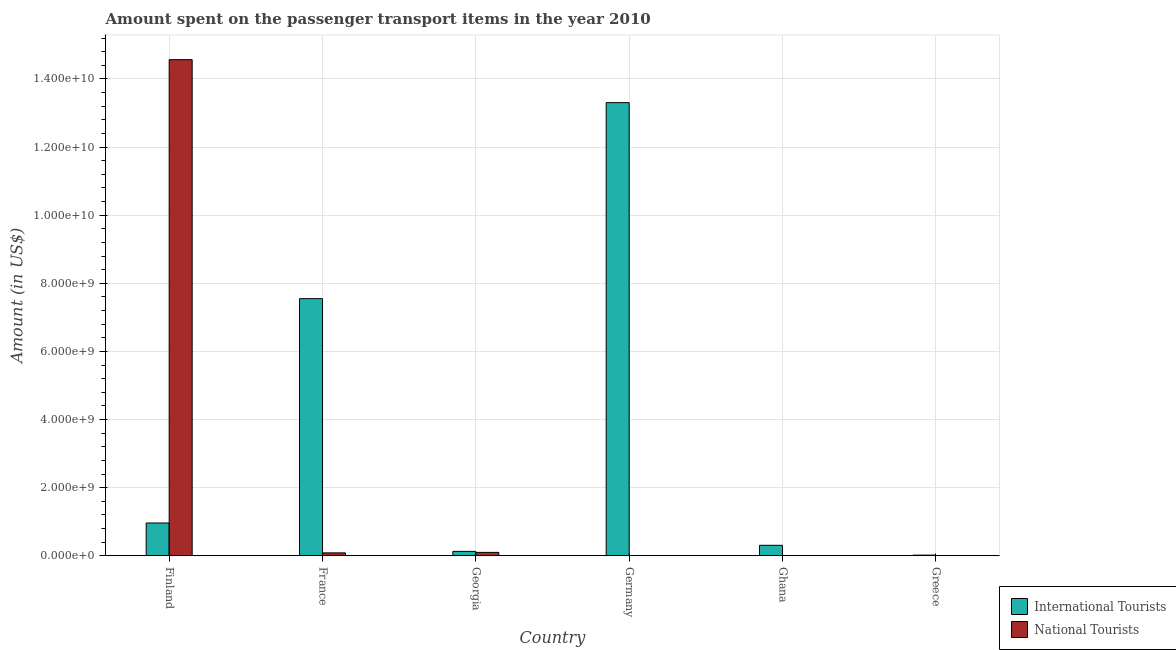Are the number of bars per tick equal to the number of legend labels?
Keep it short and to the point. Yes. Are the number of bars on each tick of the X-axis equal?
Make the answer very short. Yes. How many bars are there on the 2nd tick from the left?
Provide a succinct answer. 2. How many bars are there on the 4th tick from the right?
Provide a succinct answer. 2. What is the amount spent on transport items of national tourists in Greece?
Your answer should be compact. 1.70e+06. Across all countries, what is the maximum amount spent on transport items of national tourists?
Offer a very short reply. 1.46e+1. In which country was the amount spent on transport items of national tourists maximum?
Your answer should be compact. Finland. What is the total amount spent on transport items of international tourists in the graph?
Your response must be concise. 2.23e+1. What is the difference between the amount spent on transport items of national tourists in Georgia and that in Germany?
Provide a short and direct response. 1.00e+08. What is the difference between the amount spent on transport items of national tourists in Ghana and the amount spent on transport items of international tourists in Greece?
Make the answer very short. -1.97e+07. What is the average amount spent on transport items of national tourists per country?
Your answer should be very brief. 2.46e+09. What is the difference between the amount spent on transport items of international tourists and amount spent on transport items of national tourists in Ghana?
Offer a terse response. 3.08e+08. What is the ratio of the amount spent on transport items of national tourists in Germany to that in Ghana?
Offer a terse response. 0.13. Is the amount spent on transport items of international tourists in Germany less than that in Ghana?
Offer a very short reply. No. Is the difference between the amount spent on transport items of national tourists in Georgia and Germany greater than the difference between the amount spent on transport items of international tourists in Georgia and Germany?
Provide a short and direct response. Yes. What is the difference between the highest and the second highest amount spent on transport items of national tourists?
Ensure brevity in your answer.  1.45e+1. What is the difference between the highest and the lowest amount spent on transport items of international tourists?
Offer a terse response. 1.33e+1. Is the sum of the amount spent on transport items of international tourists in Finland and Germany greater than the maximum amount spent on transport items of national tourists across all countries?
Ensure brevity in your answer.  No. What does the 1st bar from the left in Finland represents?
Your answer should be compact. International Tourists. What does the 1st bar from the right in Ghana represents?
Provide a short and direct response. National Tourists. How many bars are there?
Ensure brevity in your answer.  12. How many countries are there in the graph?
Provide a succinct answer. 6. What is the difference between two consecutive major ticks on the Y-axis?
Offer a terse response. 2.00e+09. Are the values on the major ticks of Y-axis written in scientific E-notation?
Your answer should be compact. Yes. Does the graph contain any zero values?
Ensure brevity in your answer.  No. Does the graph contain grids?
Ensure brevity in your answer.  Yes. Where does the legend appear in the graph?
Keep it short and to the point. Bottom right. How many legend labels are there?
Offer a very short reply. 2. How are the legend labels stacked?
Provide a short and direct response. Vertical. What is the title of the graph?
Make the answer very short. Amount spent on the passenger transport items in the year 2010. What is the label or title of the X-axis?
Your answer should be compact. Country. What is the Amount (in US$) in International Tourists in Finland?
Your answer should be compact. 9.63e+08. What is the Amount (in US$) of National Tourists in Finland?
Your answer should be very brief. 1.46e+1. What is the Amount (in US$) in International Tourists in France?
Provide a short and direct response. 7.55e+09. What is the Amount (in US$) in National Tourists in France?
Your answer should be compact. 8.60e+07. What is the Amount (in US$) of International Tourists in Georgia?
Make the answer very short. 1.30e+08. What is the Amount (in US$) of National Tourists in Georgia?
Your answer should be very brief. 1.00e+08. What is the Amount (in US$) in International Tourists in Germany?
Provide a short and direct response. 1.33e+1. What is the Amount (in US$) of International Tourists in Ghana?
Keep it short and to the point. 3.08e+08. What is the Amount (in US$) in National Tourists in Greece?
Your answer should be very brief. 1.70e+06. Across all countries, what is the maximum Amount (in US$) of International Tourists?
Your answer should be very brief. 1.33e+1. Across all countries, what is the maximum Amount (in US$) in National Tourists?
Offer a terse response. 1.46e+1. Across all countries, what is the minimum Amount (in US$) in National Tourists?
Offer a terse response. 4.00e+04. What is the total Amount (in US$) of International Tourists in the graph?
Give a very brief answer. 2.23e+1. What is the total Amount (in US$) of National Tourists in the graph?
Your answer should be compact. 1.48e+1. What is the difference between the Amount (in US$) of International Tourists in Finland and that in France?
Your answer should be compact. -6.59e+09. What is the difference between the Amount (in US$) of National Tourists in Finland and that in France?
Give a very brief answer. 1.45e+1. What is the difference between the Amount (in US$) of International Tourists in Finland and that in Georgia?
Keep it short and to the point. 8.33e+08. What is the difference between the Amount (in US$) of National Tourists in Finland and that in Georgia?
Keep it short and to the point. 1.45e+1. What is the difference between the Amount (in US$) of International Tourists in Finland and that in Germany?
Give a very brief answer. -1.23e+1. What is the difference between the Amount (in US$) of National Tourists in Finland and that in Germany?
Keep it short and to the point. 1.46e+1. What is the difference between the Amount (in US$) of International Tourists in Finland and that in Ghana?
Make the answer very short. 6.55e+08. What is the difference between the Amount (in US$) of National Tourists in Finland and that in Ghana?
Give a very brief answer. 1.46e+1. What is the difference between the Amount (in US$) in International Tourists in Finland and that in Greece?
Provide a short and direct response. 9.43e+08. What is the difference between the Amount (in US$) of National Tourists in Finland and that in Greece?
Your response must be concise. 1.46e+1. What is the difference between the Amount (in US$) of International Tourists in France and that in Georgia?
Your response must be concise. 7.42e+09. What is the difference between the Amount (in US$) in National Tourists in France and that in Georgia?
Give a very brief answer. -1.40e+07. What is the difference between the Amount (in US$) in International Tourists in France and that in Germany?
Offer a terse response. -5.75e+09. What is the difference between the Amount (in US$) in National Tourists in France and that in Germany?
Your answer should be very brief. 8.60e+07. What is the difference between the Amount (in US$) in International Tourists in France and that in Ghana?
Your response must be concise. 7.24e+09. What is the difference between the Amount (in US$) of National Tourists in France and that in Ghana?
Give a very brief answer. 8.57e+07. What is the difference between the Amount (in US$) in International Tourists in France and that in Greece?
Your answer should be compact. 7.53e+09. What is the difference between the Amount (in US$) of National Tourists in France and that in Greece?
Provide a short and direct response. 8.43e+07. What is the difference between the Amount (in US$) in International Tourists in Georgia and that in Germany?
Give a very brief answer. -1.32e+1. What is the difference between the Amount (in US$) in National Tourists in Georgia and that in Germany?
Provide a succinct answer. 1.00e+08. What is the difference between the Amount (in US$) of International Tourists in Georgia and that in Ghana?
Your answer should be very brief. -1.78e+08. What is the difference between the Amount (in US$) of National Tourists in Georgia and that in Ghana?
Give a very brief answer. 9.97e+07. What is the difference between the Amount (in US$) in International Tourists in Georgia and that in Greece?
Provide a succinct answer. 1.10e+08. What is the difference between the Amount (in US$) of National Tourists in Georgia and that in Greece?
Provide a succinct answer. 9.83e+07. What is the difference between the Amount (in US$) of International Tourists in Germany and that in Ghana?
Provide a short and direct response. 1.30e+1. What is the difference between the Amount (in US$) in National Tourists in Germany and that in Ghana?
Provide a short and direct response. -2.60e+05. What is the difference between the Amount (in US$) in International Tourists in Germany and that in Greece?
Your answer should be compact. 1.33e+1. What is the difference between the Amount (in US$) in National Tourists in Germany and that in Greece?
Offer a very short reply. -1.66e+06. What is the difference between the Amount (in US$) in International Tourists in Ghana and that in Greece?
Make the answer very short. 2.88e+08. What is the difference between the Amount (in US$) in National Tourists in Ghana and that in Greece?
Keep it short and to the point. -1.40e+06. What is the difference between the Amount (in US$) of International Tourists in Finland and the Amount (in US$) of National Tourists in France?
Provide a succinct answer. 8.77e+08. What is the difference between the Amount (in US$) of International Tourists in Finland and the Amount (in US$) of National Tourists in Georgia?
Your answer should be compact. 8.63e+08. What is the difference between the Amount (in US$) of International Tourists in Finland and the Amount (in US$) of National Tourists in Germany?
Provide a short and direct response. 9.63e+08. What is the difference between the Amount (in US$) in International Tourists in Finland and the Amount (in US$) in National Tourists in Ghana?
Ensure brevity in your answer.  9.63e+08. What is the difference between the Amount (in US$) of International Tourists in Finland and the Amount (in US$) of National Tourists in Greece?
Keep it short and to the point. 9.61e+08. What is the difference between the Amount (in US$) in International Tourists in France and the Amount (in US$) in National Tourists in Georgia?
Make the answer very short. 7.45e+09. What is the difference between the Amount (in US$) of International Tourists in France and the Amount (in US$) of National Tourists in Germany?
Provide a succinct answer. 7.55e+09. What is the difference between the Amount (in US$) of International Tourists in France and the Amount (in US$) of National Tourists in Ghana?
Make the answer very short. 7.55e+09. What is the difference between the Amount (in US$) of International Tourists in France and the Amount (in US$) of National Tourists in Greece?
Make the answer very short. 7.55e+09. What is the difference between the Amount (in US$) in International Tourists in Georgia and the Amount (in US$) in National Tourists in Germany?
Provide a succinct answer. 1.30e+08. What is the difference between the Amount (in US$) in International Tourists in Georgia and the Amount (in US$) in National Tourists in Ghana?
Offer a terse response. 1.30e+08. What is the difference between the Amount (in US$) of International Tourists in Georgia and the Amount (in US$) of National Tourists in Greece?
Keep it short and to the point. 1.28e+08. What is the difference between the Amount (in US$) in International Tourists in Germany and the Amount (in US$) in National Tourists in Ghana?
Ensure brevity in your answer.  1.33e+1. What is the difference between the Amount (in US$) in International Tourists in Germany and the Amount (in US$) in National Tourists in Greece?
Your answer should be very brief. 1.33e+1. What is the difference between the Amount (in US$) in International Tourists in Ghana and the Amount (in US$) in National Tourists in Greece?
Provide a short and direct response. 3.06e+08. What is the average Amount (in US$) of International Tourists per country?
Your response must be concise. 3.71e+09. What is the average Amount (in US$) of National Tourists per country?
Your answer should be very brief. 2.46e+09. What is the difference between the Amount (in US$) in International Tourists and Amount (in US$) in National Tourists in Finland?
Provide a succinct answer. -1.36e+1. What is the difference between the Amount (in US$) of International Tourists and Amount (in US$) of National Tourists in France?
Give a very brief answer. 7.46e+09. What is the difference between the Amount (in US$) in International Tourists and Amount (in US$) in National Tourists in Georgia?
Offer a terse response. 3.00e+07. What is the difference between the Amount (in US$) in International Tourists and Amount (in US$) in National Tourists in Germany?
Offer a terse response. 1.33e+1. What is the difference between the Amount (in US$) of International Tourists and Amount (in US$) of National Tourists in Ghana?
Provide a succinct answer. 3.08e+08. What is the difference between the Amount (in US$) of International Tourists and Amount (in US$) of National Tourists in Greece?
Give a very brief answer. 1.83e+07. What is the ratio of the Amount (in US$) in International Tourists in Finland to that in France?
Offer a terse response. 0.13. What is the ratio of the Amount (in US$) of National Tourists in Finland to that in France?
Provide a succinct answer. 169.35. What is the ratio of the Amount (in US$) in International Tourists in Finland to that in Georgia?
Provide a succinct answer. 7.41. What is the ratio of the Amount (in US$) in National Tourists in Finland to that in Georgia?
Provide a succinct answer. 145.64. What is the ratio of the Amount (in US$) of International Tourists in Finland to that in Germany?
Your answer should be compact. 0.07. What is the ratio of the Amount (in US$) in National Tourists in Finland to that in Germany?
Your answer should be compact. 3.64e+05. What is the ratio of the Amount (in US$) in International Tourists in Finland to that in Ghana?
Your answer should be compact. 3.13. What is the ratio of the Amount (in US$) in National Tourists in Finland to that in Ghana?
Give a very brief answer. 4.85e+04. What is the ratio of the Amount (in US$) in International Tourists in Finland to that in Greece?
Provide a succinct answer. 48.15. What is the ratio of the Amount (in US$) of National Tourists in Finland to that in Greece?
Make the answer very short. 8567.06. What is the ratio of the Amount (in US$) in International Tourists in France to that in Georgia?
Keep it short and to the point. 58.07. What is the ratio of the Amount (in US$) in National Tourists in France to that in Georgia?
Offer a very short reply. 0.86. What is the ratio of the Amount (in US$) of International Tourists in France to that in Germany?
Offer a terse response. 0.57. What is the ratio of the Amount (in US$) of National Tourists in France to that in Germany?
Provide a succinct answer. 2150. What is the ratio of the Amount (in US$) in International Tourists in France to that in Ghana?
Provide a short and direct response. 24.51. What is the ratio of the Amount (in US$) of National Tourists in France to that in Ghana?
Make the answer very short. 286.67. What is the ratio of the Amount (in US$) of International Tourists in France to that in Greece?
Ensure brevity in your answer.  377.45. What is the ratio of the Amount (in US$) of National Tourists in France to that in Greece?
Ensure brevity in your answer.  50.59. What is the ratio of the Amount (in US$) in International Tourists in Georgia to that in Germany?
Provide a short and direct response. 0.01. What is the ratio of the Amount (in US$) in National Tourists in Georgia to that in Germany?
Provide a short and direct response. 2500. What is the ratio of the Amount (in US$) in International Tourists in Georgia to that in Ghana?
Make the answer very short. 0.42. What is the ratio of the Amount (in US$) in National Tourists in Georgia to that in Ghana?
Give a very brief answer. 333.33. What is the ratio of the Amount (in US$) in National Tourists in Georgia to that in Greece?
Provide a succinct answer. 58.82. What is the ratio of the Amount (in US$) of International Tourists in Germany to that in Ghana?
Your answer should be very brief. 43.19. What is the ratio of the Amount (in US$) of National Tourists in Germany to that in Ghana?
Provide a succinct answer. 0.13. What is the ratio of the Amount (in US$) in International Tourists in Germany to that in Greece?
Provide a short and direct response. 665.15. What is the ratio of the Amount (in US$) of National Tourists in Germany to that in Greece?
Provide a short and direct response. 0.02. What is the ratio of the Amount (in US$) of National Tourists in Ghana to that in Greece?
Provide a short and direct response. 0.18. What is the difference between the highest and the second highest Amount (in US$) of International Tourists?
Your answer should be compact. 5.75e+09. What is the difference between the highest and the second highest Amount (in US$) of National Tourists?
Give a very brief answer. 1.45e+1. What is the difference between the highest and the lowest Amount (in US$) of International Tourists?
Your answer should be very brief. 1.33e+1. What is the difference between the highest and the lowest Amount (in US$) in National Tourists?
Your response must be concise. 1.46e+1. 